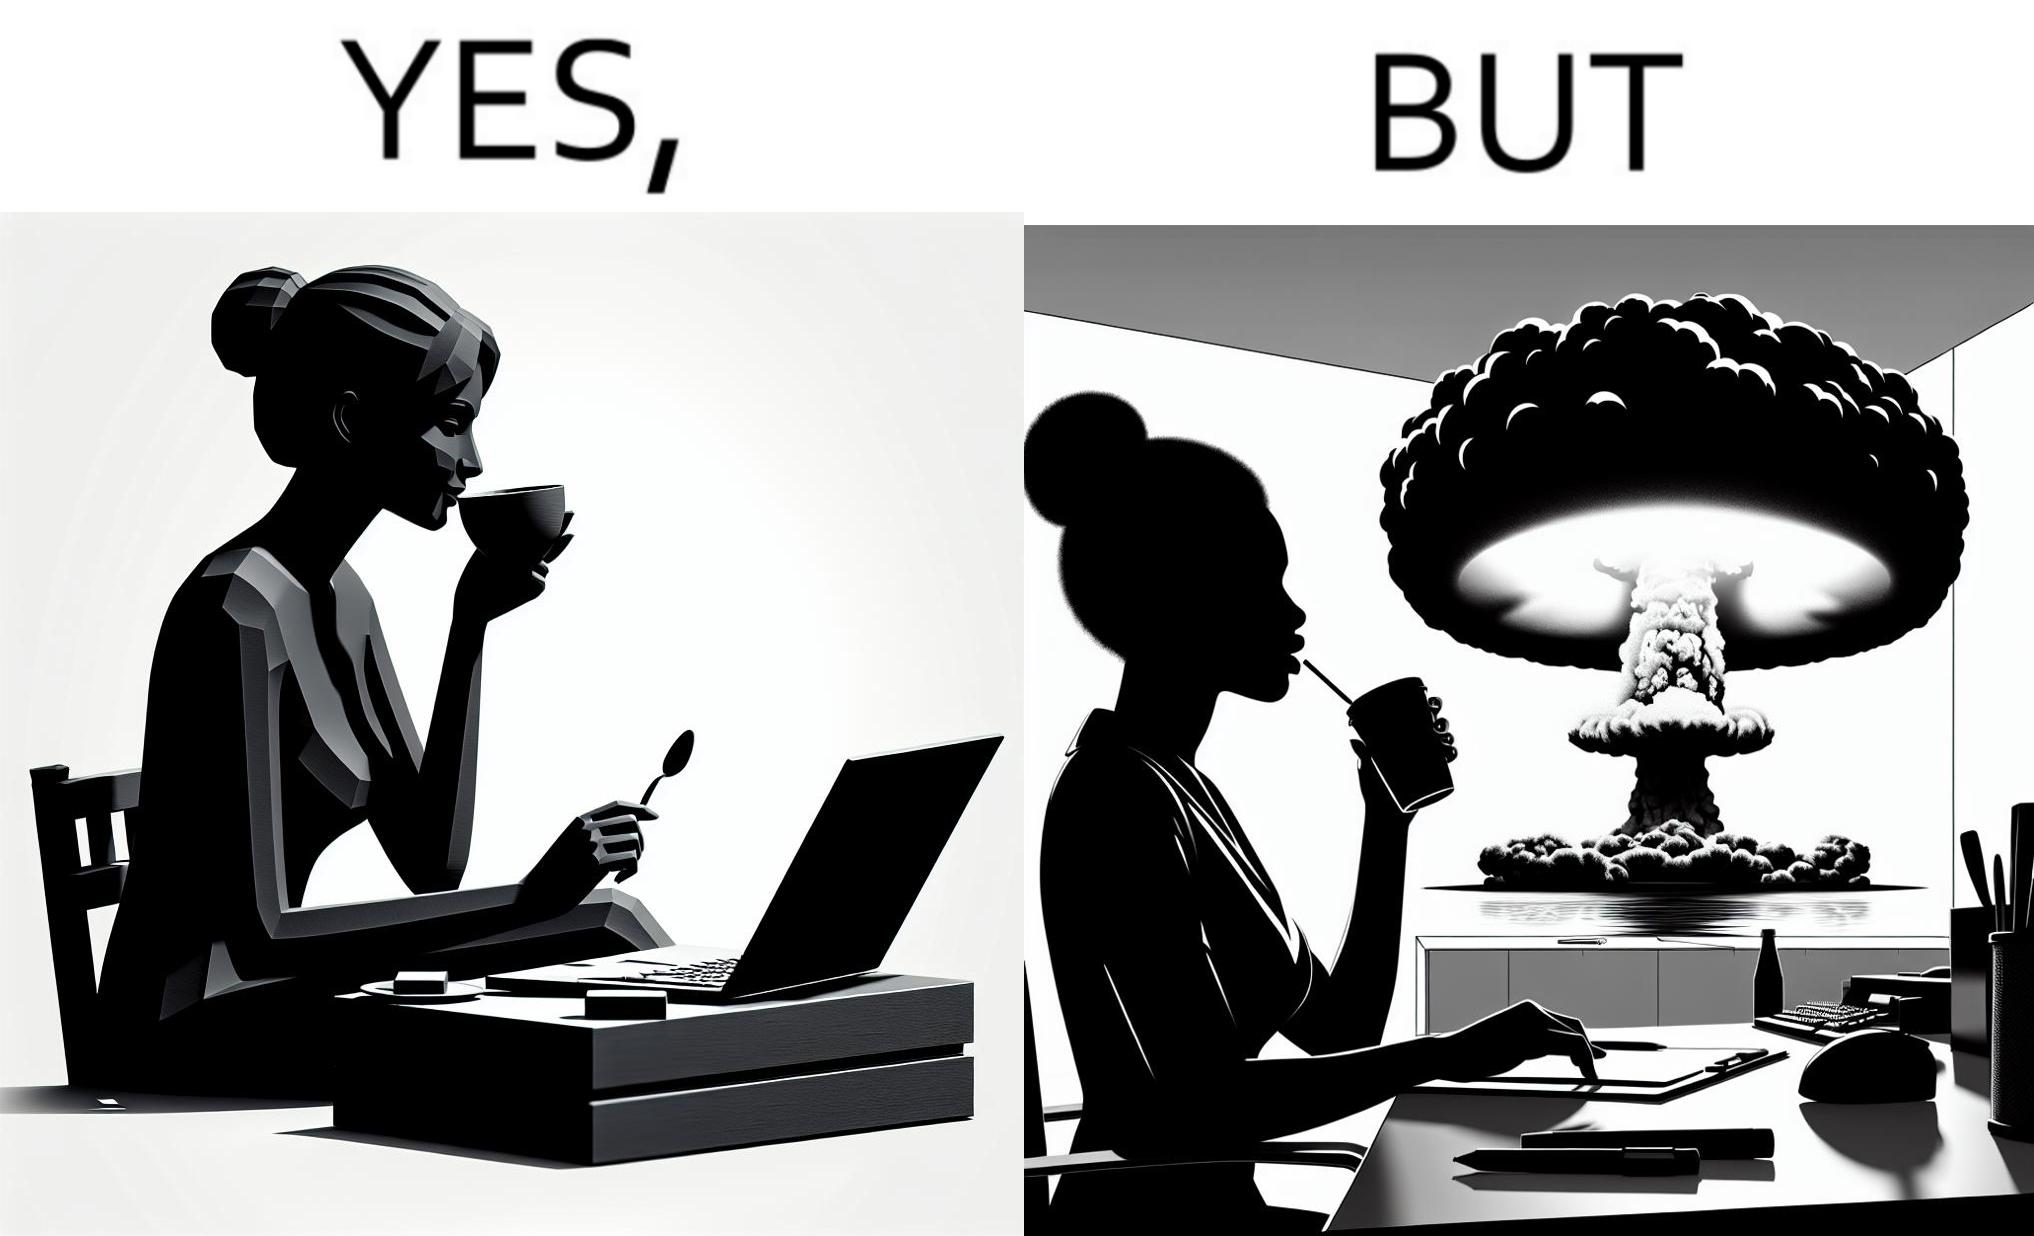Describe the satirical element in this image. The images are funny since it shows a woman simply sipping from a cup at ease in a cafe with her laptop not caring about anything going on outside the cafe even though the situation is very grave,that is, a nuclear blast 